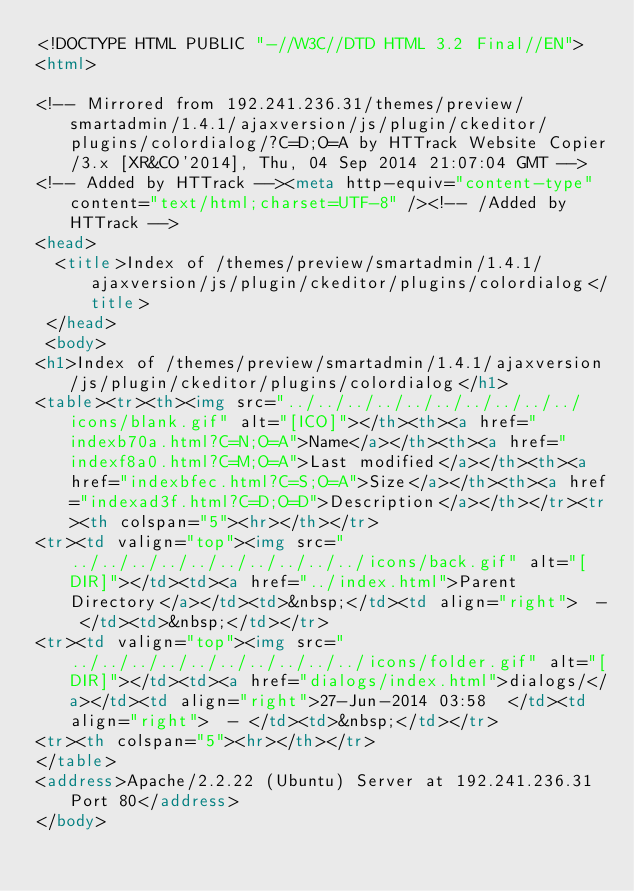Convert code to text. <code><loc_0><loc_0><loc_500><loc_500><_HTML_><!DOCTYPE HTML PUBLIC "-//W3C//DTD HTML 3.2 Final//EN">
<html>
 
<!-- Mirrored from 192.241.236.31/themes/preview/smartadmin/1.4.1/ajaxversion/js/plugin/ckeditor/plugins/colordialog/?C=D;O=A by HTTrack Website Copier/3.x [XR&CO'2014], Thu, 04 Sep 2014 21:07:04 GMT -->
<!-- Added by HTTrack --><meta http-equiv="content-type" content="text/html;charset=UTF-8" /><!-- /Added by HTTrack -->
<head>
  <title>Index of /themes/preview/smartadmin/1.4.1/ajaxversion/js/plugin/ckeditor/plugins/colordialog</title>
 </head>
 <body>
<h1>Index of /themes/preview/smartadmin/1.4.1/ajaxversion/js/plugin/ckeditor/plugins/colordialog</h1>
<table><tr><th><img src="../../../../../../../../../../icons/blank.gif" alt="[ICO]"></th><th><a href="indexb70a.html?C=N;O=A">Name</a></th><th><a href="indexf8a0.html?C=M;O=A">Last modified</a></th><th><a href="indexbfec.html?C=S;O=A">Size</a></th><th><a href="indexad3f.html?C=D;O=D">Description</a></th></tr><tr><th colspan="5"><hr></th></tr>
<tr><td valign="top"><img src="../../../../../../../../../../icons/back.gif" alt="[DIR]"></td><td><a href="../index.html">Parent Directory</a></td><td>&nbsp;</td><td align="right">  - </td><td>&nbsp;</td></tr>
<tr><td valign="top"><img src="../../../../../../../../../../icons/folder.gif" alt="[DIR]"></td><td><a href="dialogs/index.html">dialogs/</a></td><td align="right">27-Jun-2014 03:58  </td><td align="right">  - </td><td>&nbsp;</td></tr>
<tr><th colspan="5"><hr></th></tr>
</table>
<address>Apache/2.2.22 (Ubuntu) Server at 192.241.236.31 Port 80</address>
</body></code> 